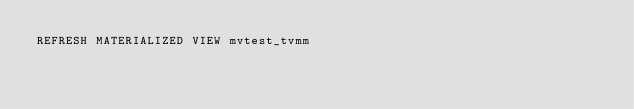Convert code to text. <code><loc_0><loc_0><loc_500><loc_500><_SQL_>REFRESH MATERIALIZED VIEW mvtest_tvmm
</code> 